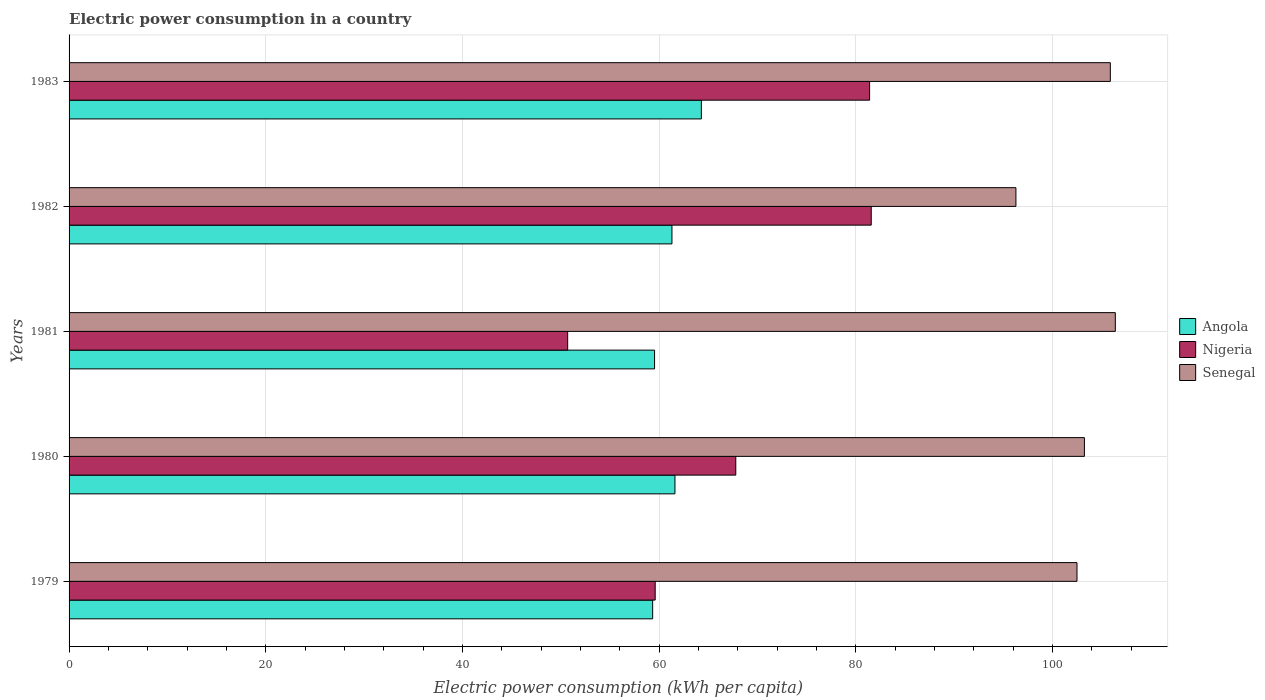How many different coloured bars are there?
Give a very brief answer. 3. How many groups of bars are there?
Offer a very short reply. 5. Are the number of bars per tick equal to the number of legend labels?
Provide a short and direct response. Yes. What is the label of the 3rd group of bars from the top?
Provide a succinct answer. 1981. In how many cases, is the number of bars for a given year not equal to the number of legend labels?
Provide a succinct answer. 0. What is the electric power consumption in in Angola in 1981?
Ensure brevity in your answer.  59.54. Across all years, what is the maximum electric power consumption in in Angola?
Your answer should be very brief. 64.3. Across all years, what is the minimum electric power consumption in in Senegal?
Give a very brief answer. 96.29. What is the total electric power consumption in in Senegal in the graph?
Ensure brevity in your answer.  514.35. What is the difference between the electric power consumption in in Angola in 1980 and that in 1982?
Provide a succinct answer. 0.31. What is the difference between the electric power consumption in in Nigeria in 1981 and the electric power consumption in in Senegal in 1982?
Give a very brief answer. -45.59. What is the average electric power consumption in in Senegal per year?
Provide a succinct answer. 102.87. In the year 1979, what is the difference between the electric power consumption in in Angola and electric power consumption in in Senegal?
Your answer should be very brief. -43.15. What is the ratio of the electric power consumption in in Nigeria in 1979 to that in 1983?
Ensure brevity in your answer.  0.73. What is the difference between the highest and the second highest electric power consumption in in Nigeria?
Keep it short and to the point. 0.16. What is the difference between the highest and the lowest electric power consumption in in Nigeria?
Provide a short and direct response. 30.87. What does the 3rd bar from the top in 1983 represents?
Offer a terse response. Angola. What does the 1st bar from the bottom in 1979 represents?
Your answer should be compact. Angola. How many bars are there?
Your answer should be very brief. 15. Are all the bars in the graph horizontal?
Offer a terse response. Yes. What is the difference between two consecutive major ticks on the X-axis?
Provide a short and direct response. 20. Where does the legend appear in the graph?
Provide a short and direct response. Center right. What is the title of the graph?
Offer a terse response. Electric power consumption in a country. What is the label or title of the X-axis?
Keep it short and to the point. Electric power consumption (kWh per capita). What is the label or title of the Y-axis?
Keep it short and to the point. Years. What is the Electric power consumption (kWh per capita) of Angola in 1979?
Your answer should be very brief. 59.35. What is the Electric power consumption (kWh per capita) of Nigeria in 1979?
Your answer should be compact. 59.61. What is the Electric power consumption (kWh per capita) in Senegal in 1979?
Your answer should be compact. 102.5. What is the Electric power consumption (kWh per capita) of Angola in 1980?
Give a very brief answer. 61.62. What is the Electric power consumption (kWh per capita) in Nigeria in 1980?
Your response must be concise. 67.8. What is the Electric power consumption (kWh per capita) of Senegal in 1980?
Offer a terse response. 103.26. What is the Electric power consumption (kWh per capita) in Angola in 1981?
Give a very brief answer. 59.54. What is the Electric power consumption (kWh per capita) in Nigeria in 1981?
Provide a short and direct response. 50.71. What is the Electric power consumption (kWh per capita) in Senegal in 1981?
Your answer should be very brief. 106.4. What is the Electric power consumption (kWh per capita) in Angola in 1982?
Your response must be concise. 61.31. What is the Electric power consumption (kWh per capita) in Nigeria in 1982?
Your answer should be very brief. 81.58. What is the Electric power consumption (kWh per capita) of Senegal in 1982?
Offer a terse response. 96.29. What is the Electric power consumption (kWh per capita) in Angola in 1983?
Your response must be concise. 64.3. What is the Electric power consumption (kWh per capita) of Nigeria in 1983?
Provide a succinct answer. 81.41. What is the Electric power consumption (kWh per capita) in Senegal in 1983?
Give a very brief answer. 105.89. Across all years, what is the maximum Electric power consumption (kWh per capita) in Angola?
Offer a very short reply. 64.3. Across all years, what is the maximum Electric power consumption (kWh per capita) of Nigeria?
Provide a succinct answer. 81.58. Across all years, what is the maximum Electric power consumption (kWh per capita) in Senegal?
Your response must be concise. 106.4. Across all years, what is the minimum Electric power consumption (kWh per capita) of Angola?
Your answer should be very brief. 59.35. Across all years, what is the minimum Electric power consumption (kWh per capita) of Nigeria?
Make the answer very short. 50.71. Across all years, what is the minimum Electric power consumption (kWh per capita) in Senegal?
Make the answer very short. 96.29. What is the total Electric power consumption (kWh per capita) in Angola in the graph?
Keep it short and to the point. 306.13. What is the total Electric power consumption (kWh per capita) of Nigeria in the graph?
Your answer should be very brief. 341.11. What is the total Electric power consumption (kWh per capita) of Senegal in the graph?
Give a very brief answer. 514.35. What is the difference between the Electric power consumption (kWh per capita) of Angola in 1979 and that in 1980?
Give a very brief answer. -2.27. What is the difference between the Electric power consumption (kWh per capita) of Nigeria in 1979 and that in 1980?
Your answer should be very brief. -8.2. What is the difference between the Electric power consumption (kWh per capita) of Senegal in 1979 and that in 1980?
Your answer should be very brief. -0.75. What is the difference between the Electric power consumption (kWh per capita) in Angola in 1979 and that in 1981?
Your response must be concise. -0.19. What is the difference between the Electric power consumption (kWh per capita) in Nigeria in 1979 and that in 1981?
Keep it short and to the point. 8.9. What is the difference between the Electric power consumption (kWh per capita) of Senegal in 1979 and that in 1981?
Your response must be concise. -3.9. What is the difference between the Electric power consumption (kWh per capita) of Angola in 1979 and that in 1982?
Offer a very short reply. -1.96. What is the difference between the Electric power consumption (kWh per capita) in Nigeria in 1979 and that in 1982?
Ensure brevity in your answer.  -21.97. What is the difference between the Electric power consumption (kWh per capita) of Senegal in 1979 and that in 1982?
Your answer should be very brief. 6.21. What is the difference between the Electric power consumption (kWh per capita) in Angola in 1979 and that in 1983?
Ensure brevity in your answer.  -4.95. What is the difference between the Electric power consumption (kWh per capita) of Nigeria in 1979 and that in 1983?
Provide a succinct answer. -21.81. What is the difference between the Electric power consumption (kWh per capita) in Senegal in 1979 and that in 1983?
Provide a succinct answer. -3.39. What is the difference between the Electric power consumption (kWh per capita) of Angola in 1980 and that in 1981?
Your answer should be very brief. 2.07. What is the difference between the Electric power consumption (kWh per capita) of Nigeria in 1980 and that in 1981?
Provide a succinct answer. 17.1. What is the difference between the Electric power consumption (kWh per capita) in Senegal in 1980 and that in 1981?
Your answer should be compact. -3.15. What is the difference between the Electric power consumption (kWh per capita) of Angola in 1980 and that in 1982?
Offer a terse response. 0.31. What is the difference between the Electric power consumption (kWh per capita) in Nigeria in 1980 and that in 1982?
Offer a terse response. -13.77. What is the difference between the Electric power consumption (kWh per capita) of Senegal in 1980 and that in 1982?
Provide a short and direct response. 6.96. What is the difference between the Electric power consumption (kWh per capita) of Angola in 1980 and that in 1983?
Ensure brevity in your answer.  -2.69. What is the difference between the Electric power consumption (kWh per capita) in Nigeria in 1980 and that in 1983?
Keep it short and to the point. -13.61. What is the difference between the Electric power consumption (kWh per capita) in Senegal in 1980 and that in 1983?
Provide a succinct answer. -2.64. What is the difference between the Electric power consumption (kWh per capita) of Angola in 1981 and that in 1982?
Offer a very short reply. -1.77. What is the difference between the Electric power consumption (kWh per capita) in Nigeria in 1981 and that in 1982?
Your answer should be very brief. -30.87. What is the difference between the Electric power consumption (kWh per capita) in Senegal in 1981 and that in 1982?
Provide a short and direct response. 10.11. What is the difference between the Electric power consumption (kWh per capita) in Angola in 1981 and that in 1983?
Your response must be concise. -4.76. What is the difference between the Electric power consumption (kWh per capita) in Nigeria in 1981 and that in 1983?
Your answer should be compact. -30.71. What is the difference between the Electric power consumption (kWh per capita) of Senegal in 1981 and that in 1983?
Make the answer very short. 0.51. What is the difference between the Electric power consumption (kWh per capita) of Angola in 1982 and that in 1983?
Ensure brevity in your answer.  -2.99. What is the difference between the Electric power consumption (kWh per capita) in Nigeria in 1982 and that in 1983?
Keep it short and to the point. 0.16. What is the difference between the Electric power consumption (kWh per capita) of Senegal in 1982 and that in 1983?
Keep it short and to the point. -9.6. What is the difference between the Electric power consumption (kWh per capita) in Angola in 1979 and the Electric power consumption (kWh per capita) in Nigeria in 1980?
Offer a terse response. -8.45. What is the difference between the Electric power consumption (kWh per capita) of Angola in 1979 and the Electric power consumption (kWh per capita) of Senegal in 1980?
Your answer should be very brief. -43.91. What is the difference between the Electric power consumption (kWh per capita) in Nigeria in 1979 and the Electric power consumption (kWh per capita) in Senegal in 1980?
Provide a succinct answer. -43.65. What is the difference between the Electric power consumption (kWh per capita) in Angola in 1979 and the Electric power consumption (kWh per capita) in Nigeria in 1981?
Give a very brief answer. 8.64. What is the difference between the Electric power consumption (kWh per capita) of Angola in 1979 and the Electric power consumption (kWh per capita) of Senegal in 1981?
Your answer should be compact. -47.05. What is the difference between the Electric power consumption (kWh per capita) of Nigeria in 1979 and the Electric power consumption (kWh per capita) of Senegal in 1981?
Your answer should be compact. -46.8. What is the difference between the Electric power consumption (kWh per capita) of Angola in 1979 and the Electric power consumption (kWh per capita) of Nigeria in 1982?
Your response must be concise. -22.23. What is the difference between the Electric power consumption (kWh per capita) in Angola in 1979 and the Electric power consumption (kWh per capita) in Senegal in 1982?
Provide a succinct answer. -36.94. What is the difference between the Electric power consumption (kWh per capita) in Nigeria in 1979 and the Electric power consumption (kWh per capita) in Senegal in 1982?
Offer a terse response. -36.69. What is the difference between the Electric power consumption (kWh per capita) of Angola in 1979 and the Electric power consumption (kWh per capita) of Nigeria in 1983?
Keep it short and to the point. -22.06. What is the difference between the Electric power consumption (kWh per capita) in Angola in 1979 and the Electric power consumption (kWh per capita) in Senegal in 1983?
Your answer should be very brief. -46.54. What is the difference between the Electric power consumption (kWh per capita) in Nigeria in 1979 and the Electric power consumption (kWh per capita) in Senegal in 1983?
Provide a short and direct response. -46.29. What is the difference between the Electric power consumption (kWh per capita) of Angola in 1980 and the Electric power consumption (kWh per capita) of Nigeria in 1981?
Offer a very short reply. 10.91. What is the difference between the Electric power consumption (kWh per capita) in Angola in 1980 and the Electric power consumption (kWh per capita) in Senegal in 1981?
Provide a succinct answer. -44.79. What is the difference between the Electric power consumption (kWh per capita) of Nigeria in 1980 and the Electric power consumption (kWh per capita) of Senegal in 1981?
Your answer should be very brief. -38.6. What is the difference between the Electric power consumption (kWh per capita) in Angola in 1980 and the Electric power consumption (kWh per capita) in Nigeria in 1982?
Keep it short and to the point. -19.96. What is the difference between the Electric power consumption (kWh per capita) of Angola in 1980 and the Electric power consumption (kWh per capita) of Senegal in 1982?
Your answer should be compact. -34.68. What is the difference between the Electric power consumption (kWh per capita) of Nigeria in 1980 and the Electric power consumption (kWh per capita) of Senegal in 1982?
Provide a short and direct response. -28.49. What is the difference between the Electric power consumption (kWh per capita) in Angola in 1980 and the Electric power consumption (kWh per capita) in Nigeria in 1983?
Keep it short and to the point. -19.8. What is the difference between the Electric power consumption (kWh per capita) of Angola in 1980 and the Electric power consumption (kWh per capita) of Senegal in 1983?
Offer a very short reply. -44.28. What is the difference between the Electric power consumption (kWh per capita) in Nigeria in 1980 and the Electric power consumption (kWh per capita) in Senegal in 1983?
Give a very brief answer. -38.09. What is the difference between the Electric power consumption (kWh per capita) of Angola in 1981 and the Electric power consumption (kWh per capita) of Nigeria in 1982?
Make the answer very short. -22.03. What is the difference between the Electric power consumption (kWh per capita) in Angola in 1981 and the Electric power consumption (kWh per capita) in Senegal in 1982?
Your answer should be very brief. -36.75. What is the difference between the Electric power consumption (kWh per capita) of Nigeria in 1981 and the Electric power consumption (kWh per capita) of Senegal in 1982?
Give a very brief answer. -45.59. What is the difference between the Electric power consumption (kWh per capita) in Angola in 1981 and the Electric power consumption (kWh per capita) in Nigeria in 1983?
Ensure brevity in your answer.  -21.87. What is the difference between the Electric power consumption (kWh per capita) of Angola in 1981 and the Electric power consumption (kWh per capita) of Senegal in 1983?
Your response must be concise. -46.35. What is the difference between the Electric power consumption (kWh per capita) of Nigeria in 1981 and the Electric power consumption (kWh per capita) of Senegal in 1983?
Offer a terse response. -55.19. What is the difference between the Electric power consumption (kWh per capita) of Angola in 1982 and the Electric power consumption (kWh per capita) of Nigeria in 1983?
Provide a succinct answer. -20.1. What is the difference between the Electric power consumption (kWh per capita) in Angola in 1982 and the Electric power consumption (kWh per capita) in Senegal in 1983?
Provide a succinct answer. -44.58. What is the difference between the Electric power consumption (kWh per capita) in Nigeria in 1982 and the Electric power consumption (kWh per capita) in Senegal in 1983?
Offer a very short reply. -24.32. What is the average Electric power consumption (kWh per capita) of Angola per year?
Make the answer very short. 61.23. What is the average Electric power consumption (kWh per capita) of Nigeria per year?
Your answer should be very brief. 68.22. What is the average Electric power consumption (kWh per capita) of Senegal per year?
Your response must be concise. 102.87. In the year 1979, what is the difference between the Electric power consumption (kWh per capita) in Angola and Electric power consumption (kWh per capita) in Nigeria?
Your answer should be very brief. -0.26. In the year 1979, what is the difference between the Electric power consumption (kWh per capita) in Angola and Electric power consumption (kWh per capita) in Senegal?
Make the answer very short. -43.15. In the year 1979, what is the difference between the Electric power consumption (kWh per capita) of Nigeria and Electric power consumption (kWh per capita) of Senegal?
Your answer should be very brief. -42.89. In the year 1980, what is the difference between the Electric power consumption (kWh per capita) of Angola and Electric power consumption (kWh per capita) of Nigeria?
Offer a terse response. -6.19. In the year 1980, what is the difference between the Electric power consumption (kWh per capita) of Angola and Electric power consumption (kWh per capita) of Senegal?
Your answer should be compact. -41.64. In the year 1980, what is the difference between the Electric power consumption (kWh per capita) in Nigeria and Electric power consumption (kWh per capita) in Senegal?
Your response must be concise. -35.45. In the year 1981, what is the difference between the Electric power consumption (kWh per capita) of Angola and Electric power consumption (kWh per capita) of Nigeria?
Ensure brevity in your answer.  8.84. In the year 1981, what is the difference between the Electric power consumption (kWh per capita) of Angola and Electric power consumption (kWh per capita) of Senegal?
Your answer should be compact. -46.86. In the year 1981, what is the difference between the Electric power consumption (kWh per capita) of Nigeria and Electric power consumption (kWh per capita) of Senegal?
Offer a very short reply. -55.7. In the year 1982, what is the difference between the Electric power consumption (kWh per capita) in Angola and Electric power consumption (kWh per capita) in Nigeria?
Your response must be concise. -20.27. In the year 1982, what is the difference between the Electric power consumption (kWh per capita) in Angola and Electric power consumption (kWh per capita) in Senegal?
Ensure brevity in your answer.  -34.98. In the year 1982, what is the difference between the Electric power consumption (kWh per capita) of Nigeria and Electric power consumption (kWh per capita) of Senegal?
Offer a terse response. -14.72. In the year 1983, what is the difference between the Electric power consumption (kWh per capita) of Angola and Electric power consumption (kWh per capita) of Nigeria?
Provide a succinct answer. -17.11. In the year 1983, what is the difference between the Electric power consumption (kWh per capita) in Angola and Electric power consumption (kWh per capita) in Senegal?
Make the answer very short. -41.59. In the year 1983, what is the difference between the Electric power consumption (kWh per capita) of Nigeria and Electric power consumption (kWh per capita) of Senegal?
Ensure brevity in your answer.  -24.48. What is the ratio of the Electric power consumption (kWh per capita) of Angola in 1979 to that in 1980?
Your answer should be compact. 0.96. What is the ratio of the Electric power consumption (kWh per capita) of Nigeria in 1979 to that in 1980?
Your answer should be compact. 0.88. What is the ratio of the Electric power consumption (kWh per capita) in Senegal in 1979 to that in 1980?
Your response must be concise. 0.99. What is the ratio of the Electric power consumption (kWh per capita) in Angola in 1979 to that in 1981?
Offer a terse response. 1. What is the ratio of the Electric power consumption (kWh per capita) in Nigeria in 1979 to that in 1981?
Keep it short and to the point. 1.18. What is the ratio of the Electric power consumption (kWh per capita) of Senegal in 1979 to that in 1981?
Provide a short and direct response. 0.96. What is the ratio of the Electric power consumption (kWh per capita) of Nigeria in 1979 to that in 1982?
Offer a very short reply. 0.73. What is the ratio of the Electric power consumption (kWh per capita) of Senegal in 1979 to that in 1982?
Your response must be concise. 1.06. What is the ratio of the Electric power consumption (kWh per capita) in Angola in 1979 to that in 1983?
Give a very brief answer. 0.92. What is the ratio of the Electric power consumption (kWh per capita) of Nigeria in 1979 to that in 1983?
Offer a very short reply. 0.73. What is the ratio of the Electric power consumption (kWh per capita) in Angola in 1980 to that in 1981?
Provide a succinct answer. 1.03. What is the ratio of the Electric power consumption (kWh per capita) of Nigeria in 1980 to that in 1981?
Your response must be concise. 1.34. What is the ratio of the Electric power consumption (kWh per capita) in Senegal in 1980 to that in 1981?
Ensure brevity in your answer.  0.97. What is the ratio of the Electric power consumption (kWh per capita) in Angola in 1980 to that in 1982?
Your answer should be very brief. 1. What is the ratio of the Electric power consumption (kWh per capita) of Nigeria in 1980 to that in 1982?
Give a very brief answer. 0.83. What is the ratio of the Electric power consumption (kWh per capita) of Senegal in 1980 to that in 1982?
Offer a very short reply. 1.07. What is the ratio of the Electric power consumption (kWh per capita) of Angola in 1980 to that in 1983?
Offer a terse response. 0.96. What is the ratio of the Electric power consumption (kWh per capita) of Nigeria in 1980 to that in 1983?
Offer a terse response. 0.83. What is the ratio of the Electric power consumption (kWh per capita) in Senegal in 1980 to that in 1983?
Offer a terse response. 0.98. What is the ratio of the Electric power consumption (kWh per capita) of Angola in 1981 to that in 1982?
Your answer should be compact. 0.97. What is the ratio of the Electric power consumption (kWh per capita) of Nigeria in 1981 to that in 1982?
Give a very brief answer. 0.62. What is the ratio of the Electric power consumption (kWh per capita) of Senegal in 1981 to that in 1982?
Your response must be concise. 1.1. What is the ratio of the Electric power consumption (kWh per capita) of Angola in 1981 to that in 1983?
Provide a short and direct response. 0.93. What is the ratio of the Electric power consumption (kWh per capita) in Nigeria in 1981 to that in 1983?
Your answer should be compact. 0.62. What is the ratio of the Electric power consumption (kWh per capita) of Angola in 1982 to that in 1983?
Your answer should be very brief. 0.95. What is the ratio of the Electric power consumption (kWh per capita) of Senegal in 1982 to that in 1983?
Give a very brief answer. 0.91. What is the difference between the highest and the second highest Electric power consumption (kWh per capita) in Angola?
Give a very brief answer. 2.69. What is the difference between the highest and the second highest Electric power consumption (kWh per capita) in Nigeria?
Give a very brief answer. 0.16. What is the difference between the highest and the second highest Electric power consumption (kWh per capita) in Senegal?
Offer a terse response. 0.51. What is the difference between the highest and the lowest Electric power consumption (kWh per capita) of Angola?
Offer a terse response. 4.95. What is the difference between the highest and the lowest Electric power consumption (kWh per capita) of Nigeria?
Your answer should be very brief. 30.87. What is the difference between the highest and the lowest Electric power consumption (kWh per capita) of Senegal?
Give a very brief answer. 10.11. 